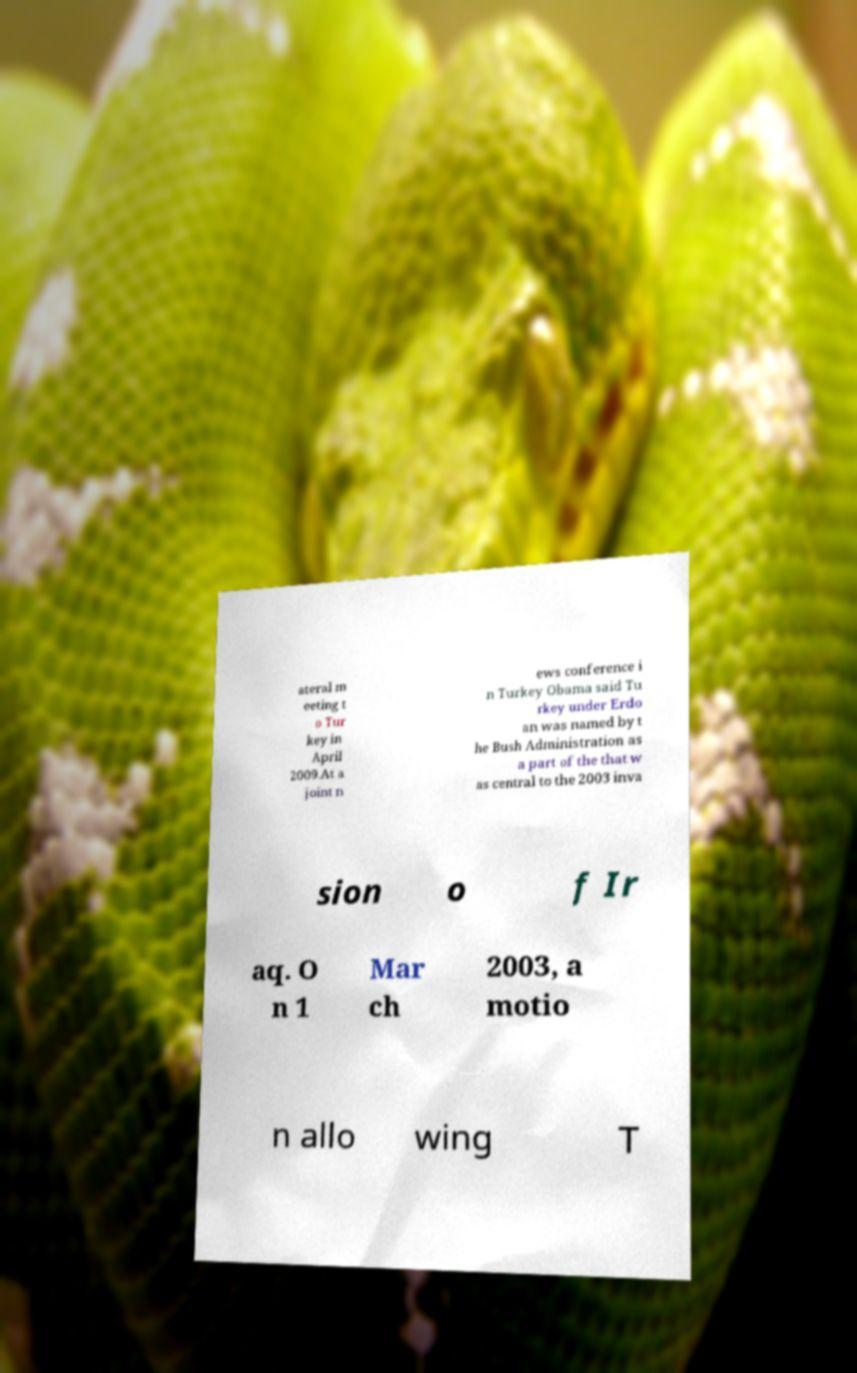Can you accurately transcribe the text from the provided image for me? ateral m eeting t o Tur key in April 2009.At a joint n ews conference i n Turkey Obama said Tu rkey under Erdo an was named by t he Bush Administration as a part of the that w as central to the 2003 inva sion o f Ir aq. O n 1 Mar ch 2003, a motio n allo wing T 